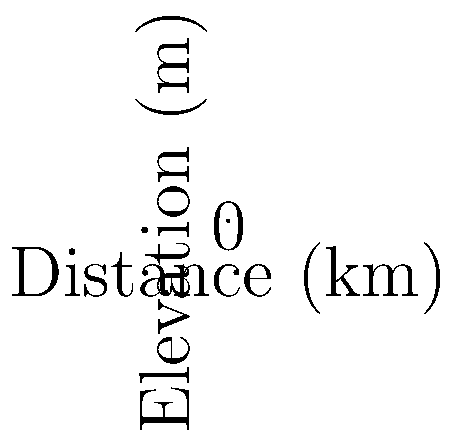Based on the before-and-after maps of Honolulu's coastline, what is the average vertical distance (in meters) between the 2023 coastline and the projected 2050 coastline? Round your answer to one decimal place. To calculate the average vertical distance between the 2023 and 2050 coastlines:

1. Identify the elevation differences at each point:
   Point 1: 1.0 - 0.5 = 0.5 m
   Point 2: 1.2 - 0.7 = 0.5 m
   Point 3: 0.8 - 0.3 = 0.5 m
   Point 4: 1.5 - 1.0 = 0.5 m
   Point 5: 1.3 - 0.8 = 0.5 m
   Point 6: 1.0 - 0.5 = 0.5 m

2. Calculate the sum of these differences:
   $0.5 + 0.5 + 0.5 + 0.5 + 0.5 + 0.5 = 3.0$ m

3. Divide the sum by the number of points (6) to get the average:
   $\frac{3.0}{6} = 0.5$ m

Therefore, the average vertical distance between the 2023 and 2050 coastlines is 0.5 meters.
Answer: 0.5 m 